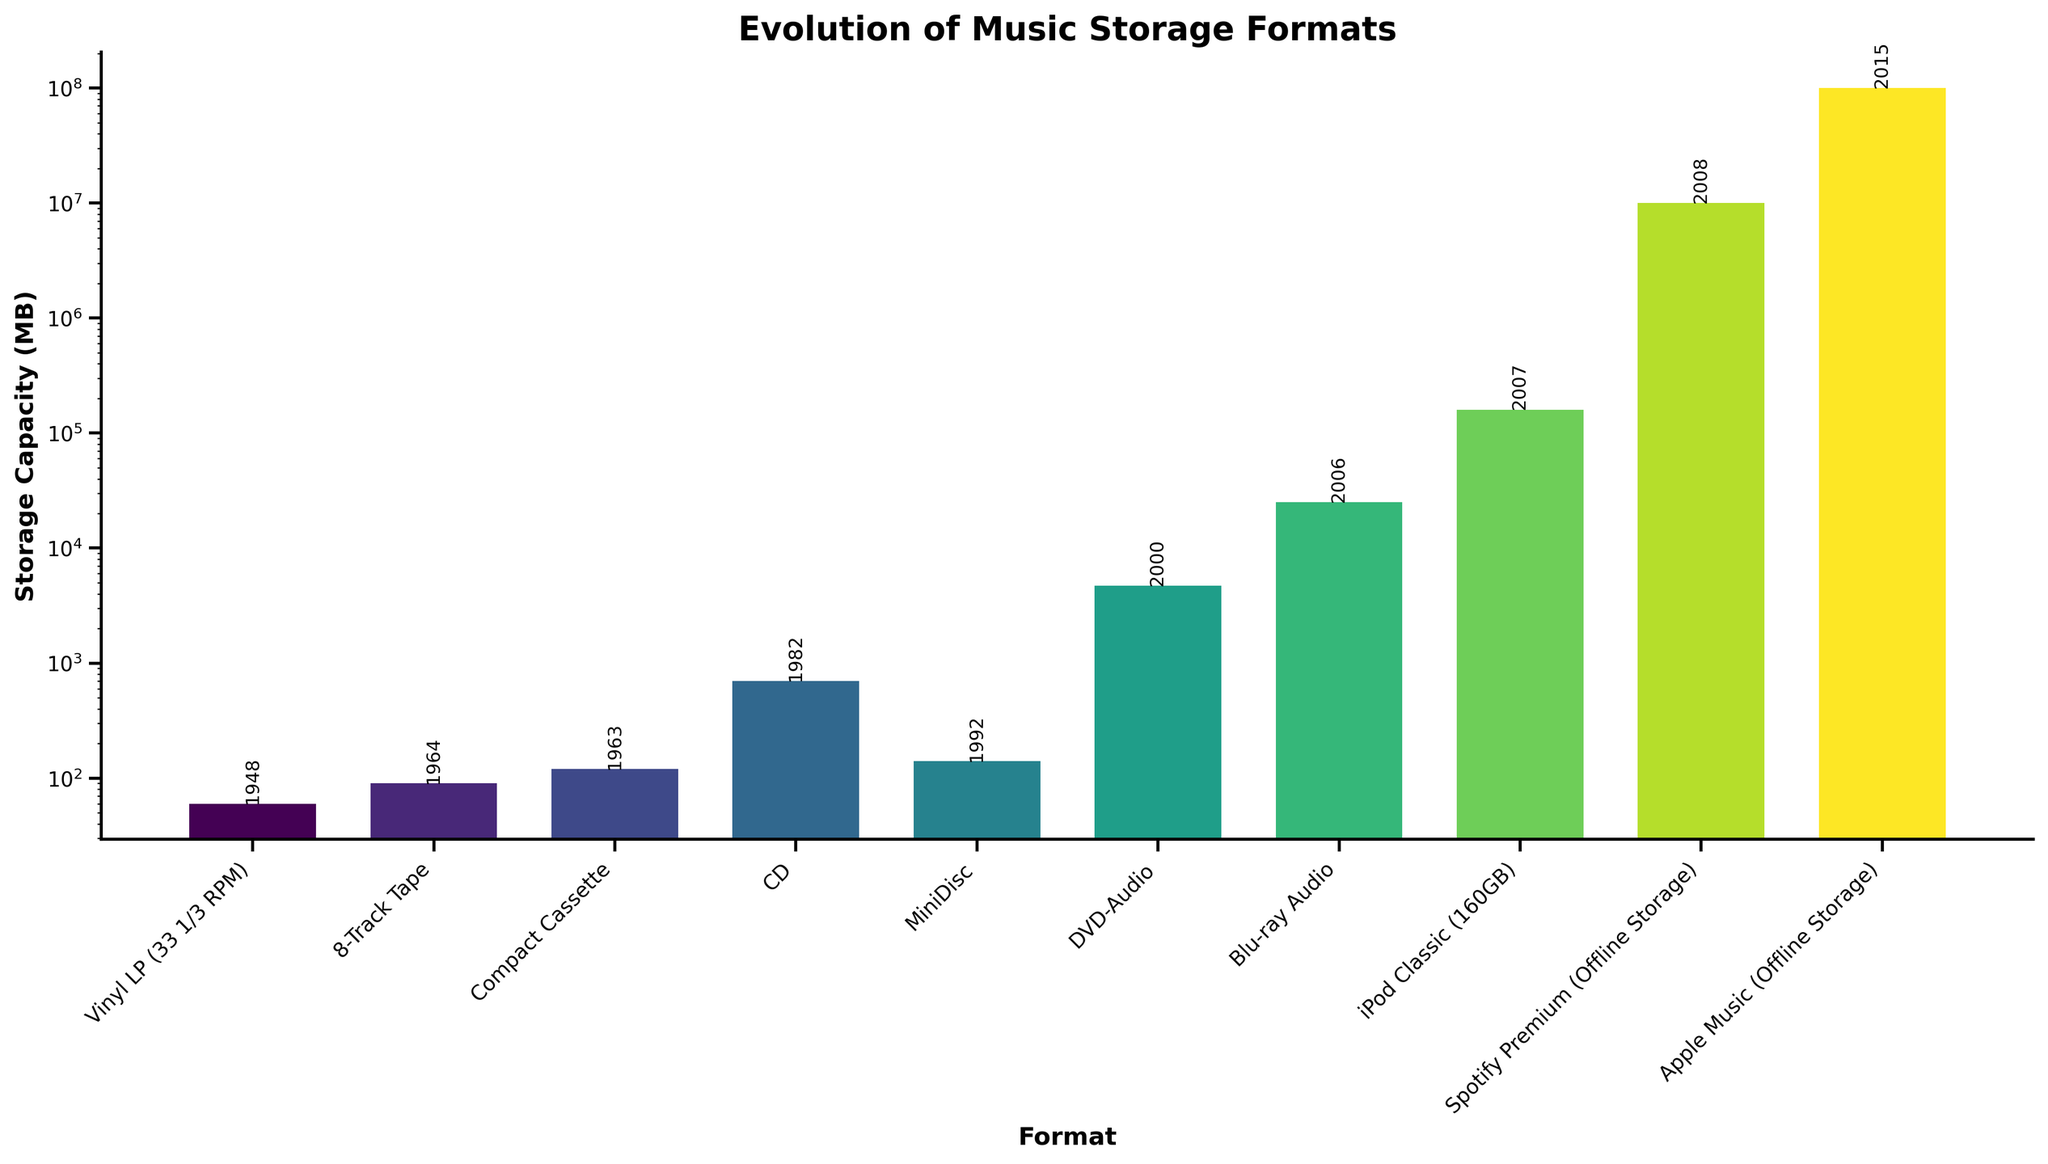Which format has the highest storage capacity? By looking at the heights of the bars, we can identify that "Apple Music (Offline Storage)" has the highest storage capacity among all the formats displayed.
Answer: Apple Music (Offline Storage) How does the storage capacity of DVDs compare to that of CDs? From the figure, the bar for DVD-Audio (4700 MB) is significantly taller than the bar for CD (700 MB). This indicates that DVDs have a much higher storage capacity compared to CDs.
Answer: DVD-Audio has a higher storage capacity Which format introduced in the 2000s has the lowest storage capacity? By identifying the formats from the 2000s and comparing their bar heights, "Spotify Premium (Offline Storage)" introduced in 2008, and "Apple Music (Offline Storage)" introduced in 2015 have higher capacities. The MiniDisc, however, introduced in 1992 has a much lower storage capacity compared to formats in the 2000s.
Answer: MiniDisc What is the combined storage capacity of 8-Track Tape and Compact Cassette? The 8-Track Tape has a storage capacity of 90 MB and the Compact Cassette has 120 MB. Adding these together gives 90 + 120 = 210 MB.
Answer: 210 MB In which year was a substantial increase in storage capacity observed from the previous format? Observing the increases in bar heights and the corresponding years, from CD (1982) to DVD-Audio (2000), there was a significant increase from 700 MB to 4700 MB.
Answer: 2000 List the formats in order of their introduction years. Reading the x-axis labels in conjunction with the annotated years on the bars, this order can be stipulated: "Vinyl LP (33 1/3 RPM)" (1948), "8-Track Tape" (1964), "Compact Cassette" (1963), "CD" (1982), "MiniDisc" (1992), "DVD-Audio" (2000), "Blu-ray Audio" (2006), "iPod Classic (160GB)" (2007), "Spotify Premium (Offline Storage)" (2008), "Apple Music (Offline Storage)" (2015).
Answer: Vinyl, 8-Track, Cassette, CD, MiniDisc, DVD, Blu-ray, iPod, Spotify, Apple Music Which format introduced before 1990 has the highest capacity? Identifying the formats introduced before 1990 and comparing their bar heights, the "Compact Cassette" (1963) has the highest capacity of 120 MB among the formats introduced in that timeframe.
Answer: Compact Cassette How much more storage does a Blu-ray Audio have compared to a MiniDisc? The storage capacity of a Blu-ray Audio is 25000 MB, while that of a MiniDisc is 140 MB. Subtracting these gives 25000 - 140 = 24860 MB.
Answer: 24860 MB What is the trend in storage capacity over time according to the figure? Observing the heights of the bars chronologically, there is a clear trend of increasing storage capacity over time, with major jumps at specific formats like CD to DVD-Audio and iPod to Spotify Premium.
Answer: Increasing If Spotify Premium was introduced in 2008, what can be inferred about storage formats introduced after this year? By recognizing the significant increase in the bar height for "Spotify Premium" and subsequently "Apple Music", it can be inferred that the storage capacities for formats introduced post-2008 have vastly increased, represented by their very large bar heights.
Answer: Vastly increased 